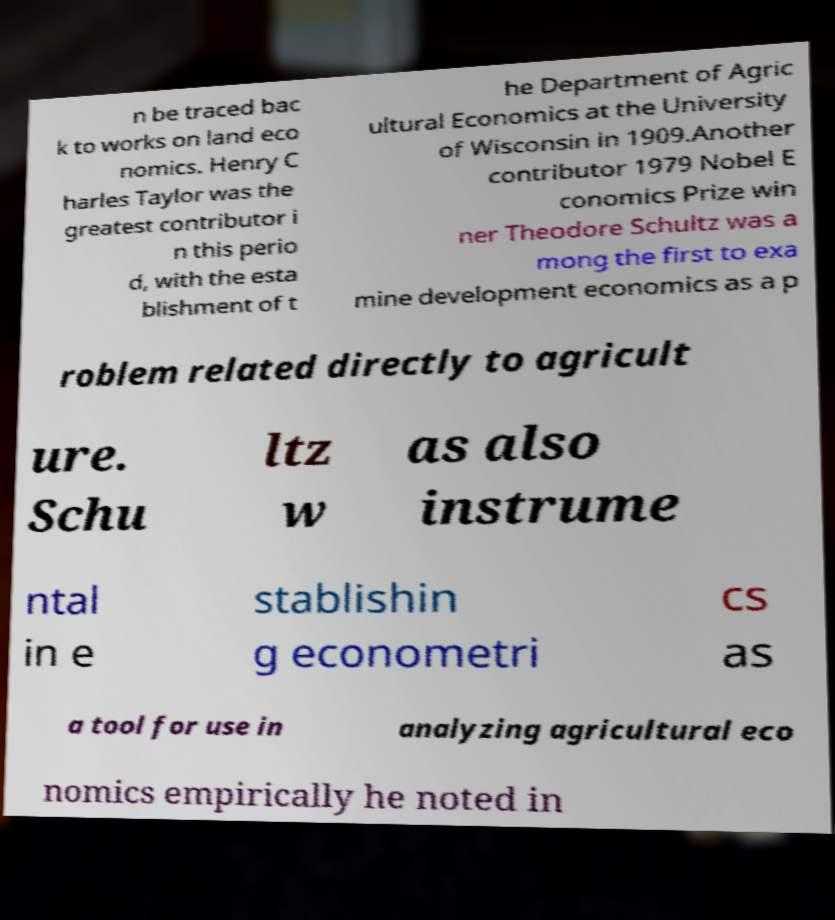For documentation purposes, I need the text within this image transcribed. Could you provide that? n be traced bac k to works on land eco nomics. Henry C harles Taylor was the greatest contributor i n this perio d, with the esta blishment of t he Department of Agric ultural Economics at the University of Wisconsin in 1909.Another contributor 1979 Nobel E conomics Prize win ner Theodore Schultz was a mong the first to exa mine development economics as a p roblem related directly to agricult ure. Schu ltz w as also instrume ntal in e stablishin g econometri cs as a tool for use in analyzing agricultural eco nomics empirically he noted in 